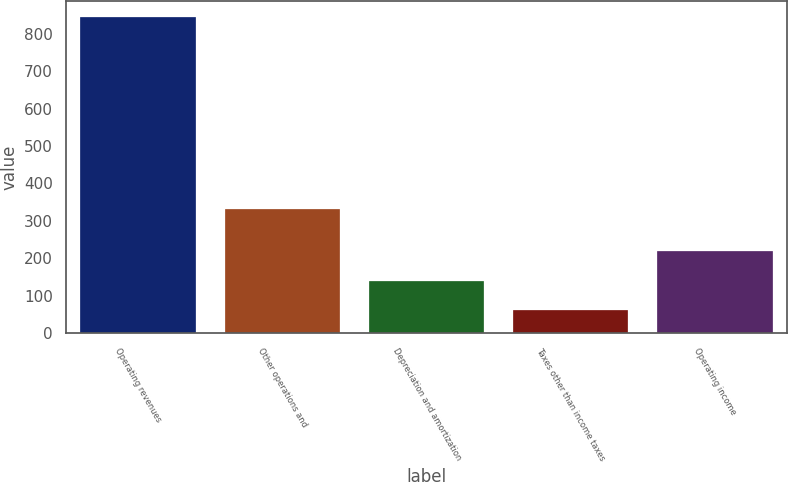<chart> <loc_0><loc_0><loc_500><loc_500><bar_chart><fcel>Operating revenues<fcel>Other operations and<fcel>Depreciation and amortization<fcel>Taxes other than income taxes<fcel>Operating income<nl><fcel>845<fcel>333<fcel>140.3<fcel>62<fcel>218.6<nl></chart> 